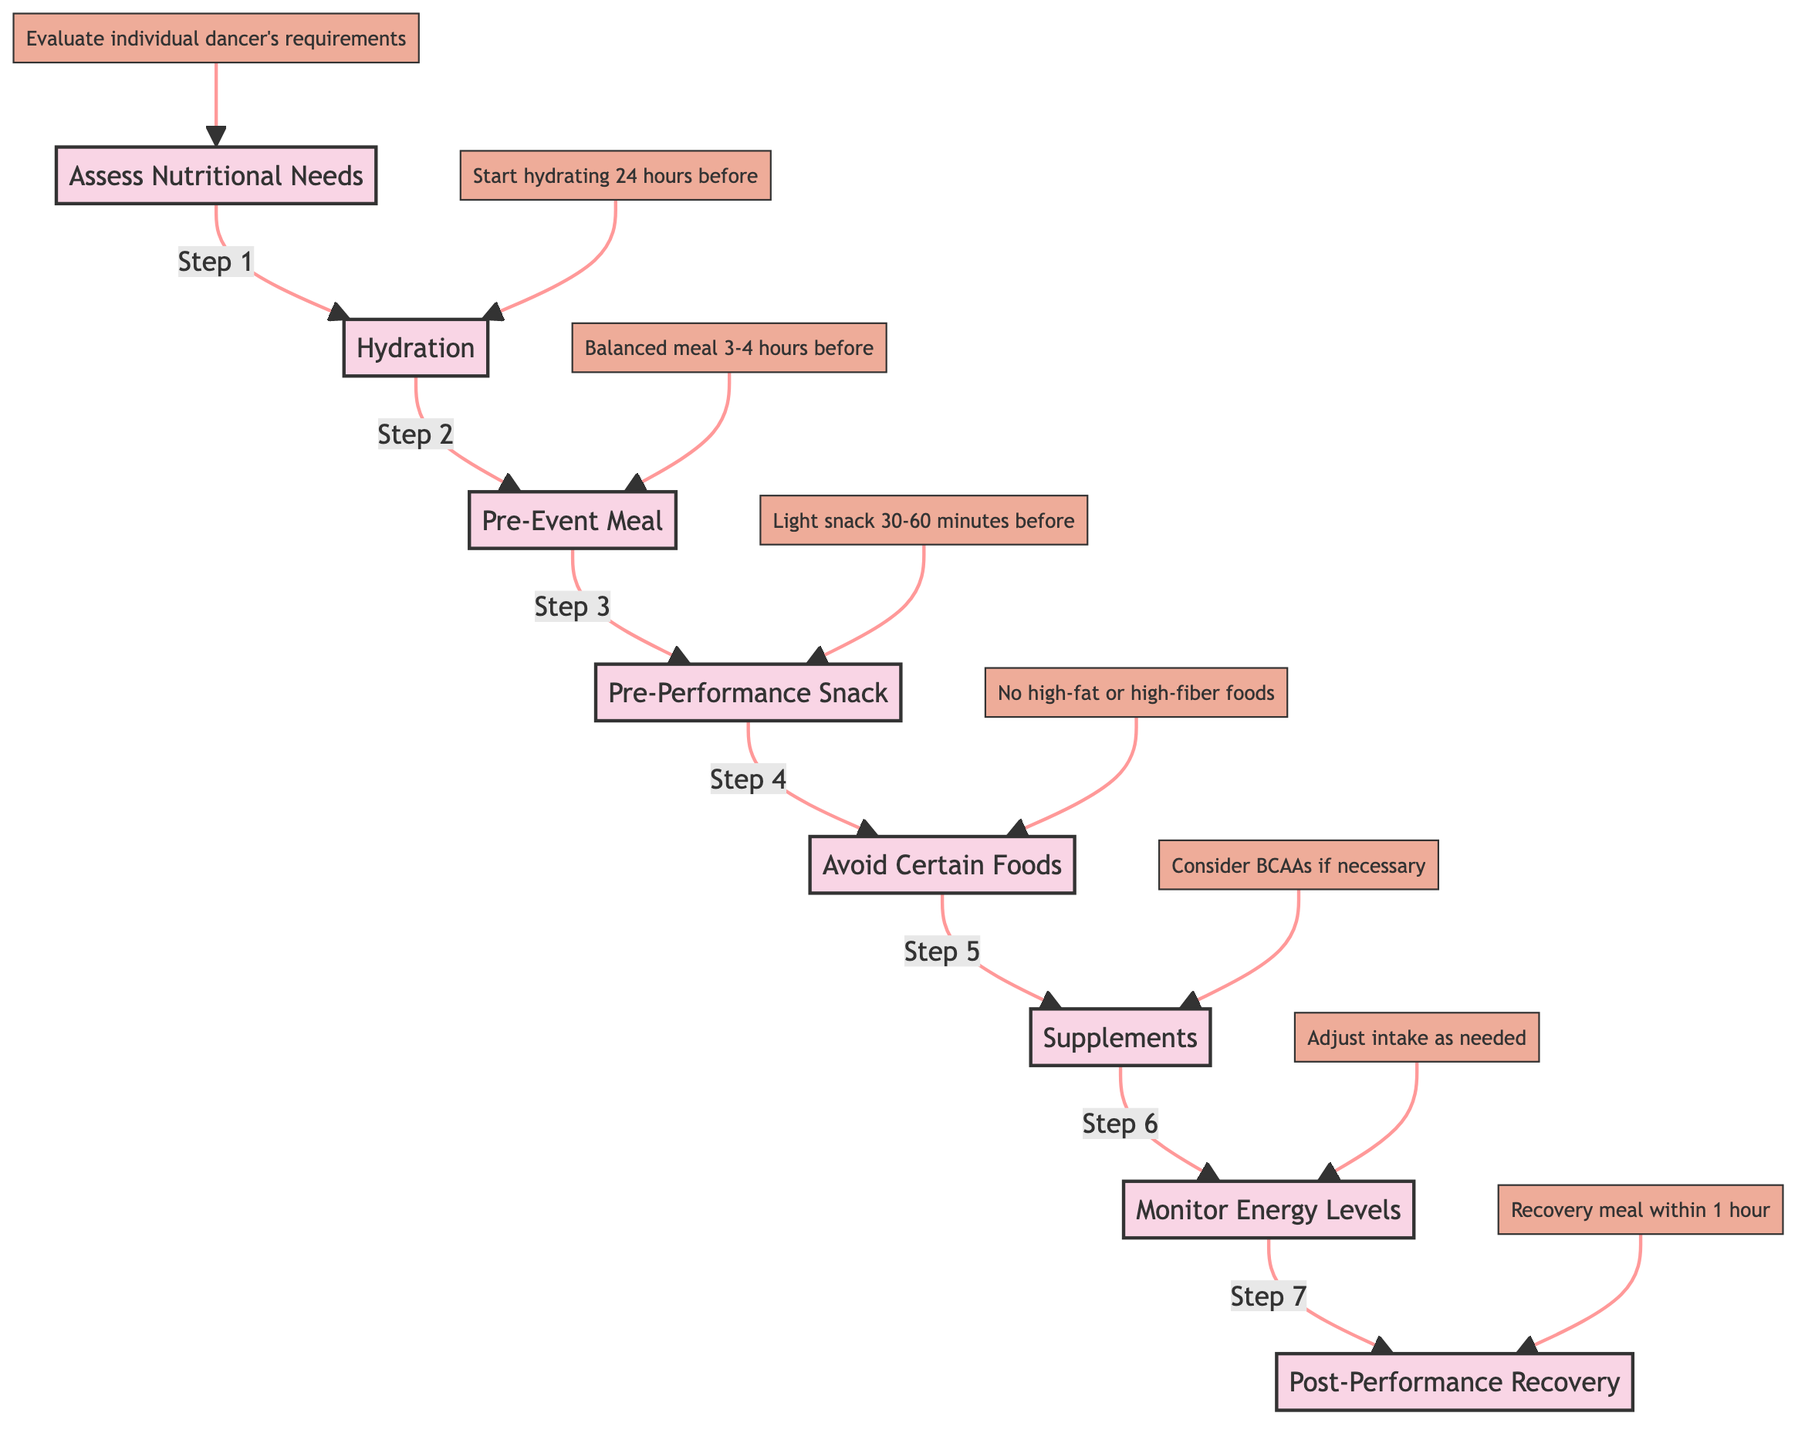what is the first step in the flow chart? The first step in the flow chart is "Assess Nutritional Needs," which is represented by the node A in the diagram.
Answer: Assess Nutritional Needs how many main steps are there in the diagram? The diagram includes a total of 8 main steps, which range from "Assess Nutritional Needs" to "Post-Performance Recovery." Each main step is represented by a node in the flow chart.
Answer: 8 what is the relationship between "Hydration" and "Pre-Event Meal"? The relationship is sequential; "Hydration" (Step 2) leads directly to "Pre-Event Meal" (Step 3) in the flow chart, indicating that hydration occurs before preparing the pre-event meal.
Answer: Sequential what should dancers consume in their pre-event meal? In their pre-event meal, dancers should consume a balanced meal that includes complex carbohydrates, lean proteins, healthy fats, and vegetables, as described in Step 3 of the diagram.
Answer: Complex carbohydrates, lean proteins, healthy fats, vegetables what action should be taken 30-60 minutes before the performance? 30-60 minutes before the performance, dancers should have a light snack according to the "Pre-Performance Snack" step in the diagram. This typically consists of options like a banana with almond butter or a small smoothie.
Answer: Light snack why should high-fat and high-fiber foods be avoided before performance? High-fat and high-fiber foods should be avoided because they can cause digestive discomfort close to performance time, as outlined in the "Avoid Certain Foods" step in the diagram.
Answer: Digestive discomfort how often should energy levels be monitored? Energy levels should be continuously monitored according to the "Monitor Energy Levels" step, which implies an ongoing assessment as dancers prepare for the performance.
Answer: Continuously what type of supplement is mentioned for muscle endurance? The supplement mentioned for muscle endurance in the "Supplements (If Needed)" step is BCAAs (Branched-Chain Amino Acids), which may be considered if necessary under the guidance of a nutritionist.
Answer: BCAAs what is recommended for recovery after the performance? A recovery meal is recommended within 1 hour after the performance, and this should include a mix of protein and carbohydrates, as described in the "Post-Performance Recovery" step of the diagram.
Answer: Recovery meal within 1 hour 